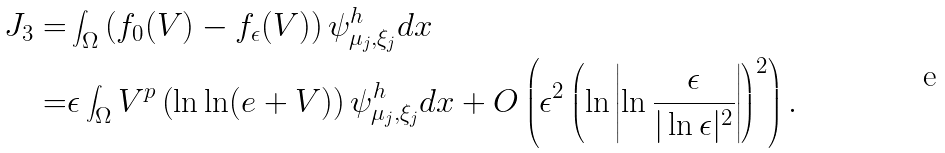<formula> <loc_0><loc_0><loc_500><loc_500>J _ { 3 } = & \int _ { \Omega } \left ( f _ { 0 } ( V ) - f _ { \epsilon } ( V ) \right ) \psi ^ { h } _ { \mu _ { j } , \xi _ { j } } d x \\ = & \epsilon \int _ { \Omega } V ^ { p } \left ( \ln \ln ( e + V ) \right ) \psi ^ { h } _ { \mu _ { j } , \xi _ { j } } d x + O \left ( \epsilon ^ { 2 } \left ( \ln \left | \ln \frac { \epsilon } { | \ln \epsilon | ^ { 2 } } \right | \right ) ^ { 2 } \right ) .</formula> 